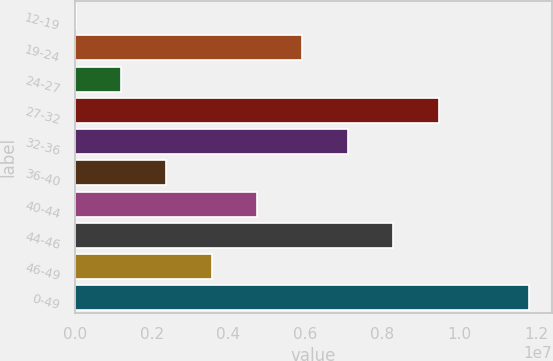Convert chart. <chart><loc_0><loc_0><loc_500><loc_500><bar_chart><fcel>12-19<fcel>19-24<fcel>24-27<fcel>27-32<fcel>32-36<fcel>36-40<fcel>40-44<fcel>44-46<fcel>46-49<fcel>0-49<nl><fcel>26500<fcel>5.92394e+06<fcel>1.20599e+06<fcel>9.46241e+06<fcel>7.10343e+06<fcel>2.38548e+06<fcel>4.74445e+06<fcel>8.28292e+06<fcel>3.56496e+06<fcel>1.18214e+07<nl></chart> 